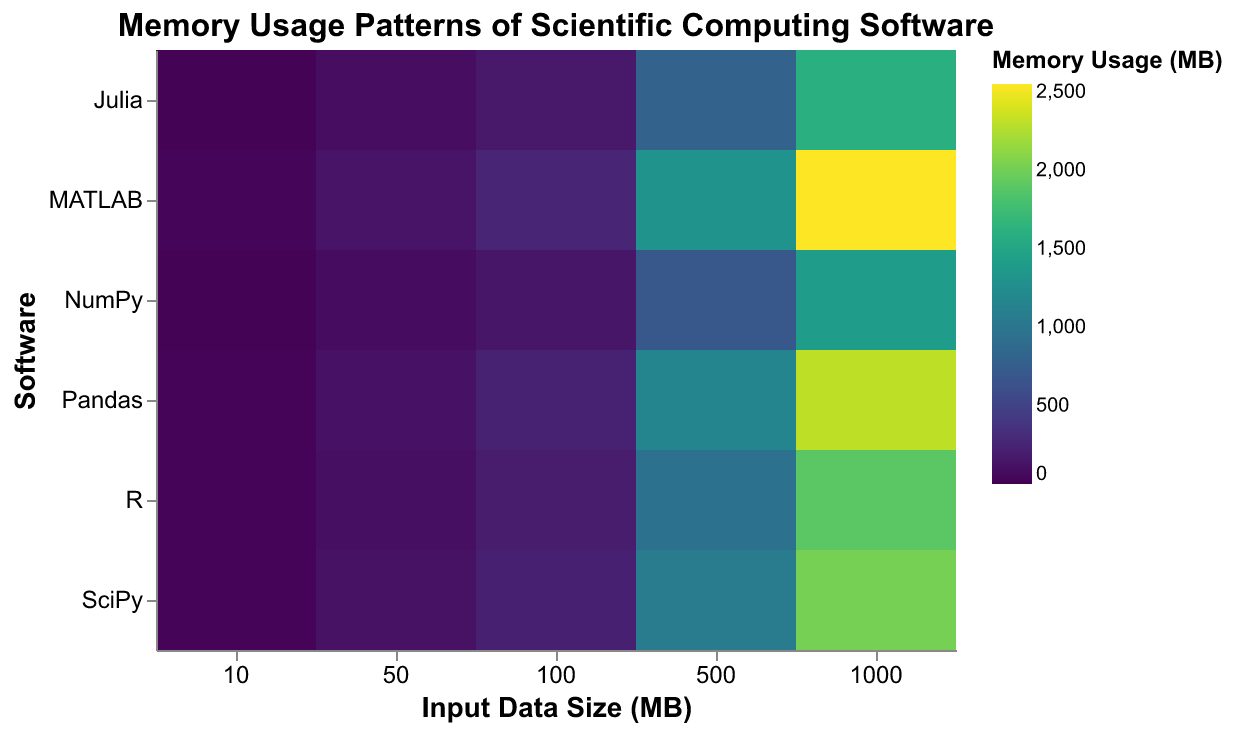What's the title of the heatmap? Look at the text centered at the top of the heatmap, which typically provides the overall description. The title is "Memory Usage Patterns of Scientific Computing Software".
Answer: Memory Usage Patterns of Scientific Computing Software Which software has the highest memory usage for the largest input data size? Identify the largest input data size on the x-axis (1000 MB), and then look for the darkest color on this vertical line in the corresponding y-axis. MATLAB has the highest memory usage at this data size, which is 2550 MB.
Answer: MATLAB At which input data size does NumPy exhibit a memory usage of 70 MB? Find the software on the y-axis labeled as "NumPy" and look for the color that corresponds to 70 MB on the color scale. Then trace vertically to the corresponding label on the x-axis. NumPy's memory usage of 70 MB occurs at an input data size of 50 MB.
Answer: 50 MB For SciPy, how does the memory usage change from an input data size of 10 MB to 100 MB? Start at the y-axis label "SciPy" and compare the colors in the columns for input data sizes of 10 MB and 100 MB. The color intensifies, indicating an increase in memory usage. Specifically, it goes from 20 MB at 10 MB to 220 MB at 100 MB, so the difference is 200 MB.
Answer: 200 MB increase Which software generally uses the least memory for input data sizes of 500 MB? Look at the row for each software at the intersection of the 500 MB column. Julia uses the least memory, as indicated by the lighter color, corresponding to 800 MB.
Answer: Julia Compare the memory usage of MATLAB and SciPy for an input data size of 500 MB. Identify the respective positions for MATLAB and SciPy (y-axis) at the 500 MB input data size (x-axis). MATLAB has a memory usage of 1300 MB, whereas SciPy has 1050 MB. MATLAB uses 250 MB more memory than SciPy.
Answer: MATLAB uses 250 MB more What is the average memory usage across all software for an input data size of 100 MB? Sum the memory usage for 100 MB input data size for all software: SciPy (220 MB), NumPy (140 MB), MATLAB (260 MB), R (190 MB), Julia (160 MB), Pandas (230 MB). The total is 220 + 140 + 260 + 190 + 160 + 230 = 1200 MB. There are 6 software, so the average is 1200 / 6 = 200 MB.
Answer: 200 MB Which software displays the most rapid increase in memory usage as the input data size increases from 50 MB to 500 MB? Calculate the difference in memory usage for each software between the input data sizes of 50 MB and 500 MB. SciPy increases by (1050 - 110) = 940 MB, NumPy by (700 - 70) = 630 MB, MATLAB by (1300 - 130) = 1170 MB, R by (950 - 95) = 855 MB, Julia by (800 - 80) = 720 MB, and Pandas by (1150 - 115) = 1035 MB. MATLAB has the highest increase, 1170 MB.
Answer: MATLAB How is the memory usage pattern of R similar to or different from that of Julia? Compare the colors of the corresponding cells for "R" and "Julia" across all input data sizes. Both software shows a consistent increase in memory usage with increasing input data sizes, and the relative intensities are similar, although R generally uses slightly more memory than Julia for the same input sizes.
Answer: R uses slightly more memory What's the memory usage for Pandas at 50 MB input data size? Locate the software "Pandas" on the y-axis and trace horizontally to the column for an input data size of 50 MB. The color here corresponds to a value of 115 MB based on the legend.
Answer: 115 MB 